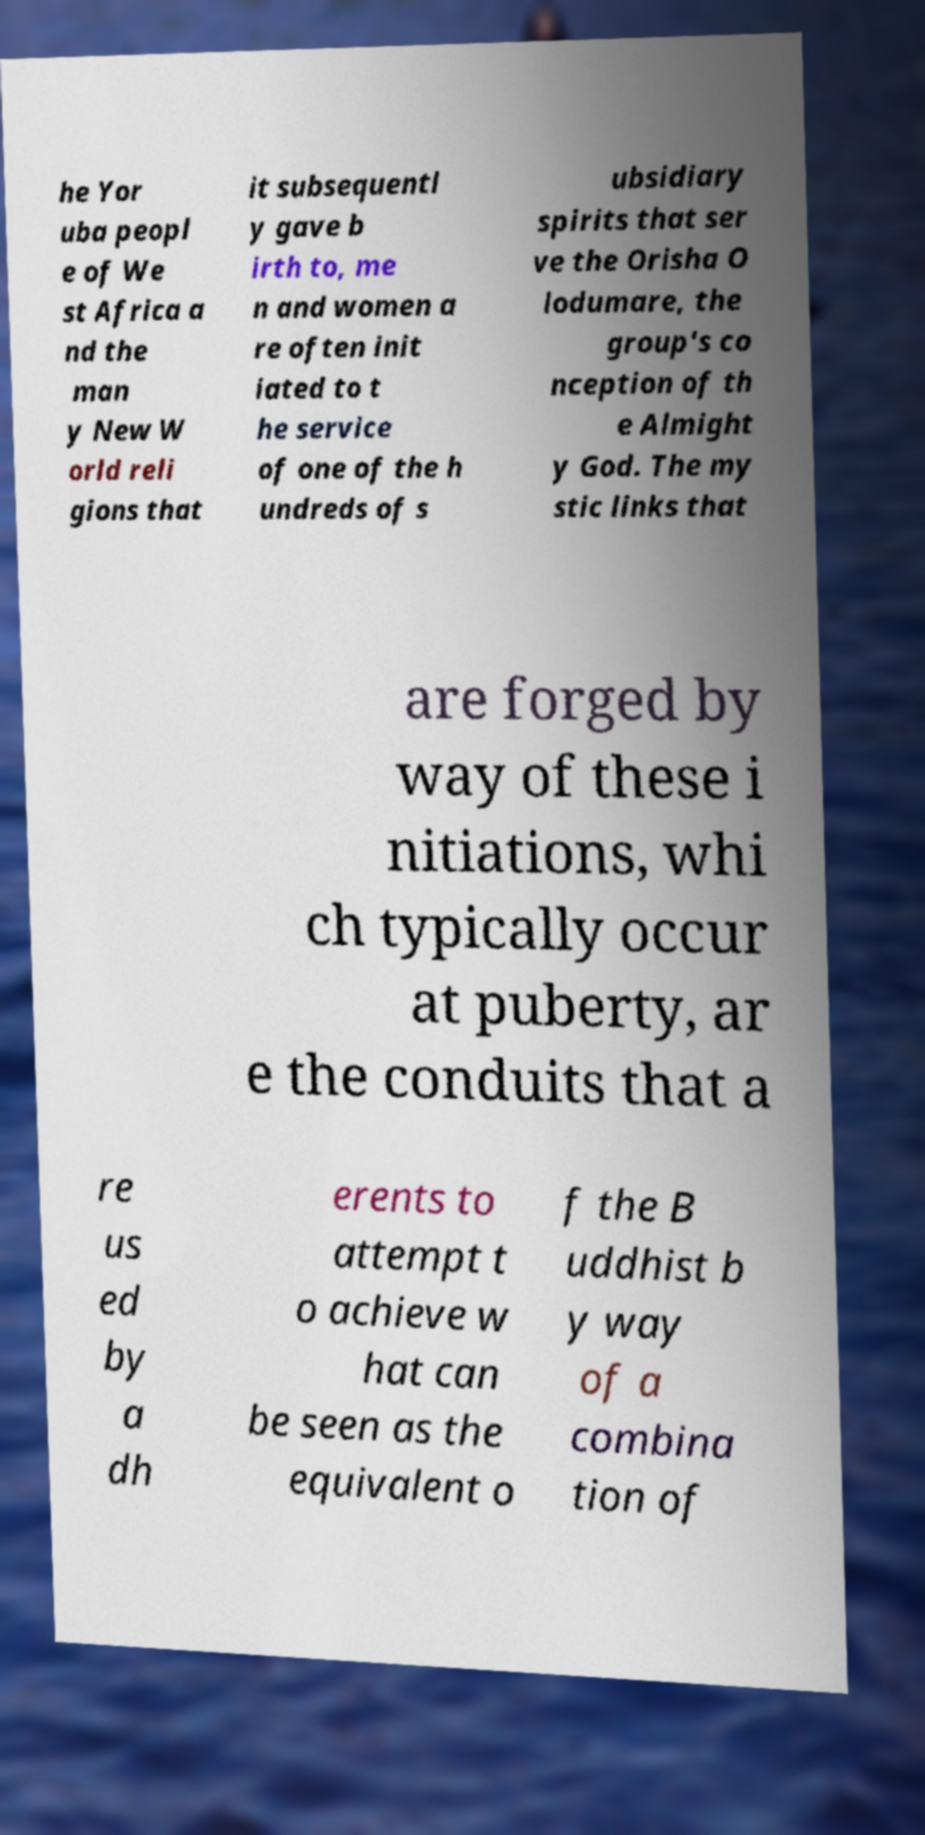Can you read and provide the text displayed in the image?This photo seems to have some interesting text. Can you extract and type it out for me? he Yor uba peopl e of We st Africa a nd the man y New W orld reli gions that it subsequentl y gave b irth to, me n and women a re often init iated to t he service of one of the h undreds of s ubsidiary spirits that ser ve the Orisha O lodumare, the group's co nception of th e Almight y God. The my stic links that are forged by way of these i nitiations, whi ch typically occur at puberty, ar e the conduits that a re us ed by a dh erents to attempt t o achieve w hat can be seen as the equivalent o f the B uddhist b y way of a combina tion of 